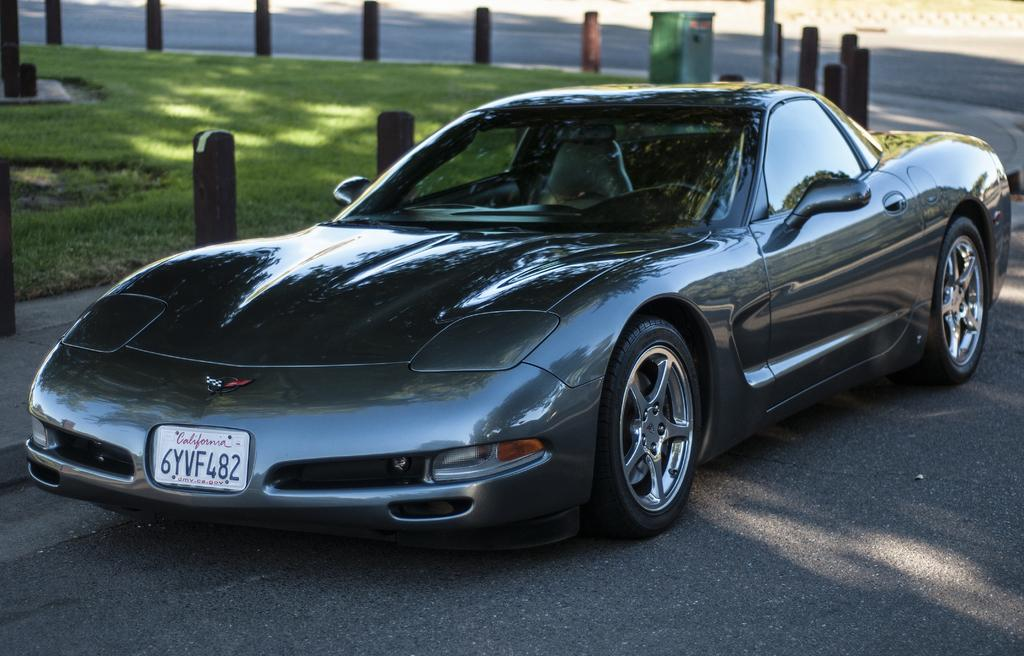What is the main subject of the image? There is a car on the road in the image. What else can be seen in the image besides the car? There are poles and grass in the image. Can you describe the green object in the image? There is a green object in the image, but its specific nature is not clear from the provided facts. What type of event is taking place at the cemetery in the image? There is no cemetery present in the image, so it is not possible to answer that question. 